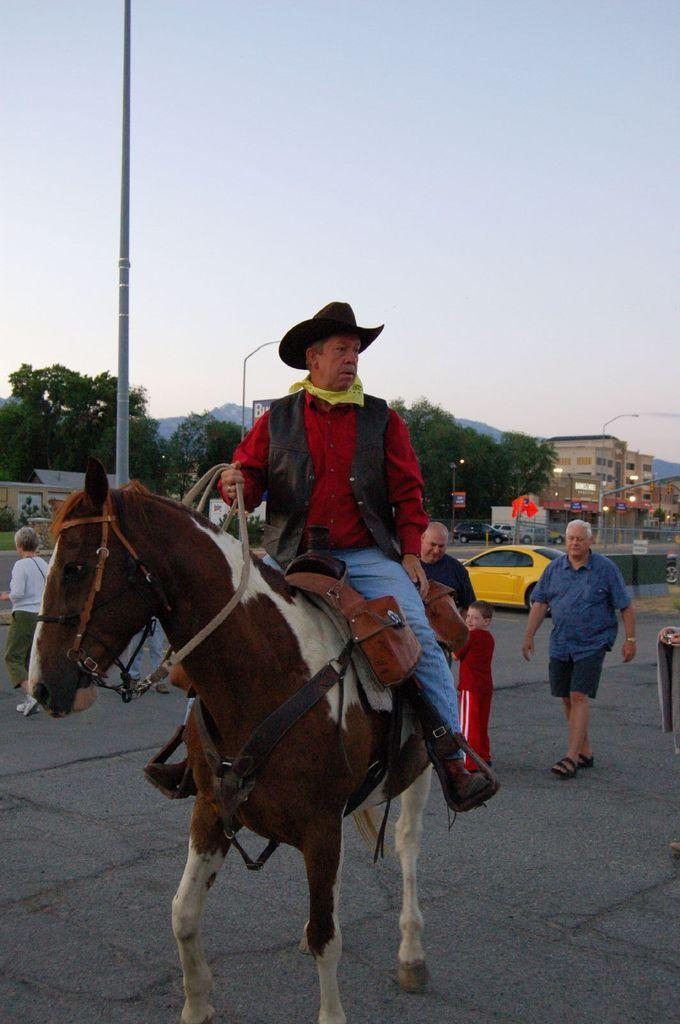Could you give a brief overview of what you see in this image? In this picture we have a person sitting on a horse wearing a red shirt and a hat. There are two persons and a boy walking behind the horse. There is a yellow color car parked behind them. In the background we have a pole, Trees and buildings and the sky is clear 